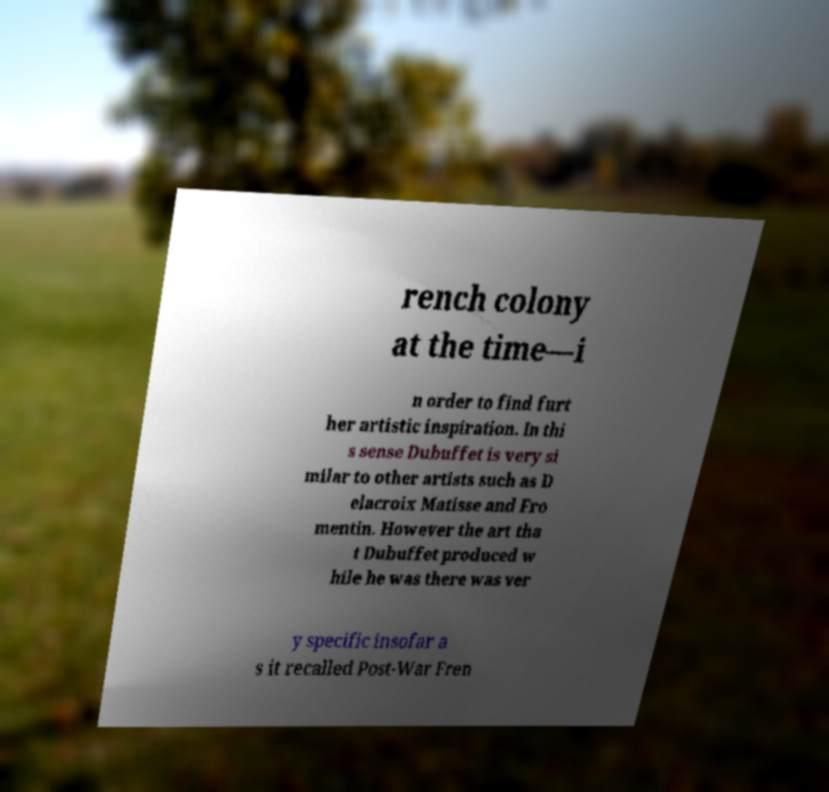Could you extract and type out the text from this image? rench colony at the time—i n order to find furt her artistic inspiration. In thi s sense Dubuffet is very si milar to other artists such as D elacroix Matisse and Fro mentin. However the art tha t Dubuffet produced w hile he was there was ver y specific insofar a s it recalled Post-War Fren 